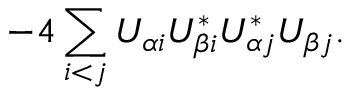Convert formula to latex. <formula><loc_0><loc_0><loc_500><loc_500>- 4 \sum _ { i < j } U _ { \alpha i } U _ { \beta i } ^ { * } U _ { \alpha j } ^ { * } U _ { \beta j } .</formula> 